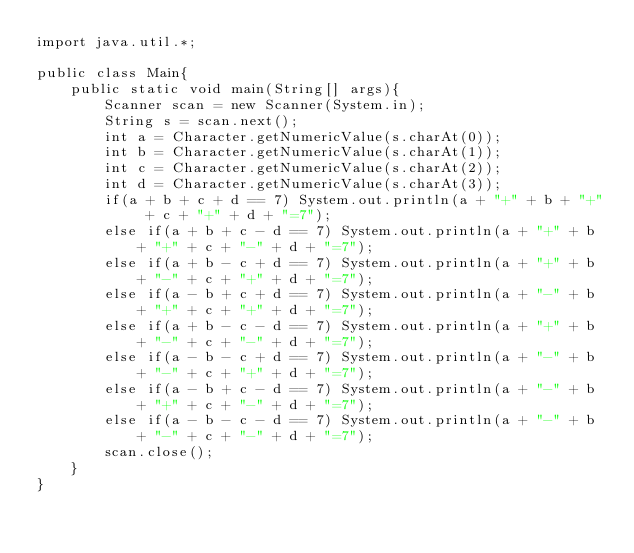Convert code to text. <code><loc_0><loc_0><loc_500><loc_500><_Java_>import java.util.*;

public class Main{
    public static void main(String[] args){
        Scanner scan = new Scanner(System.in);
        String s = scan.next();
        int a = Character.getNumericValue(s.charAt(0));
        int b = Character.getNumericValue(s.charAt(1));
        int c = Character.getNumericValue(s.charAt(2));
        int d = Character.getNumericValue(s.charAt(3));
        if(a + b + c + d == 7) System.out.println(a + "+" + b + "+" + c + "+" + d + "=7");
        else if(a + b + c - d == 7) System.out.println(a + "+" + b + "+" + c + "-" + d + "=7");
        else if(a + b - c + d == 7) System.out.println(a + "+" + b + "-" + c + "+" + d + "=7");
        else if(a - b + c + d == 7) System.out.println(a + "-" + b + "+" + c + "+" + d + "=7");
        else if(a + b - c - d == 7) System.out.println(a + "+" + b + "-" + c + "-" + d + "=7");
        else if(a - b - c + d == 7) System.out.println(a + "-" + b + "-" + c + "+" + d + "=7");
        else if(a - b + c - d == 7) System.out.println(a + "-" + b + "+" + c + "-" + d + "=7");
        else if(a - b - c - d == 7) System.out.println(a + "-" + b + "-" + c + "-" + d + "=7");
        scan.close();
    }
}</code> 